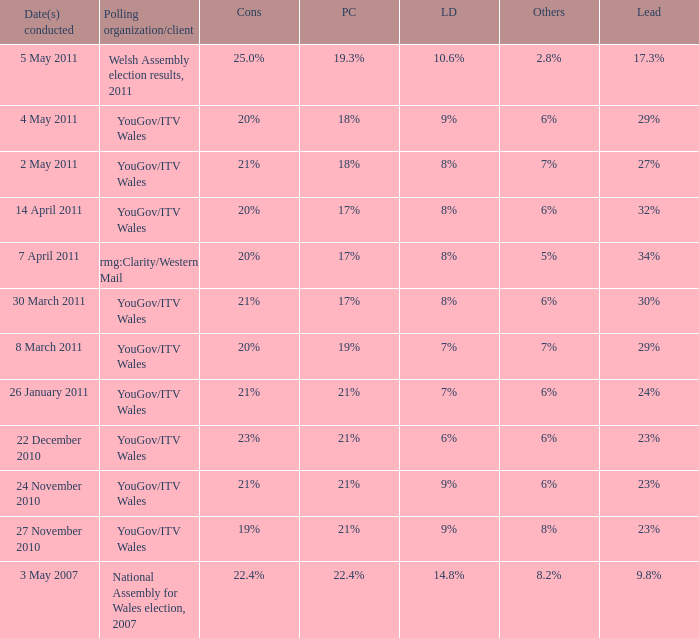Tell me the dates conducted for plaid cymru of 19% 8 March 2011. 